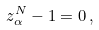<formula> <loc_0><loc_0><loc_500><loc_500>z _ { \alpha } ^ { N } - 1 = 0 \, ,</formula> 